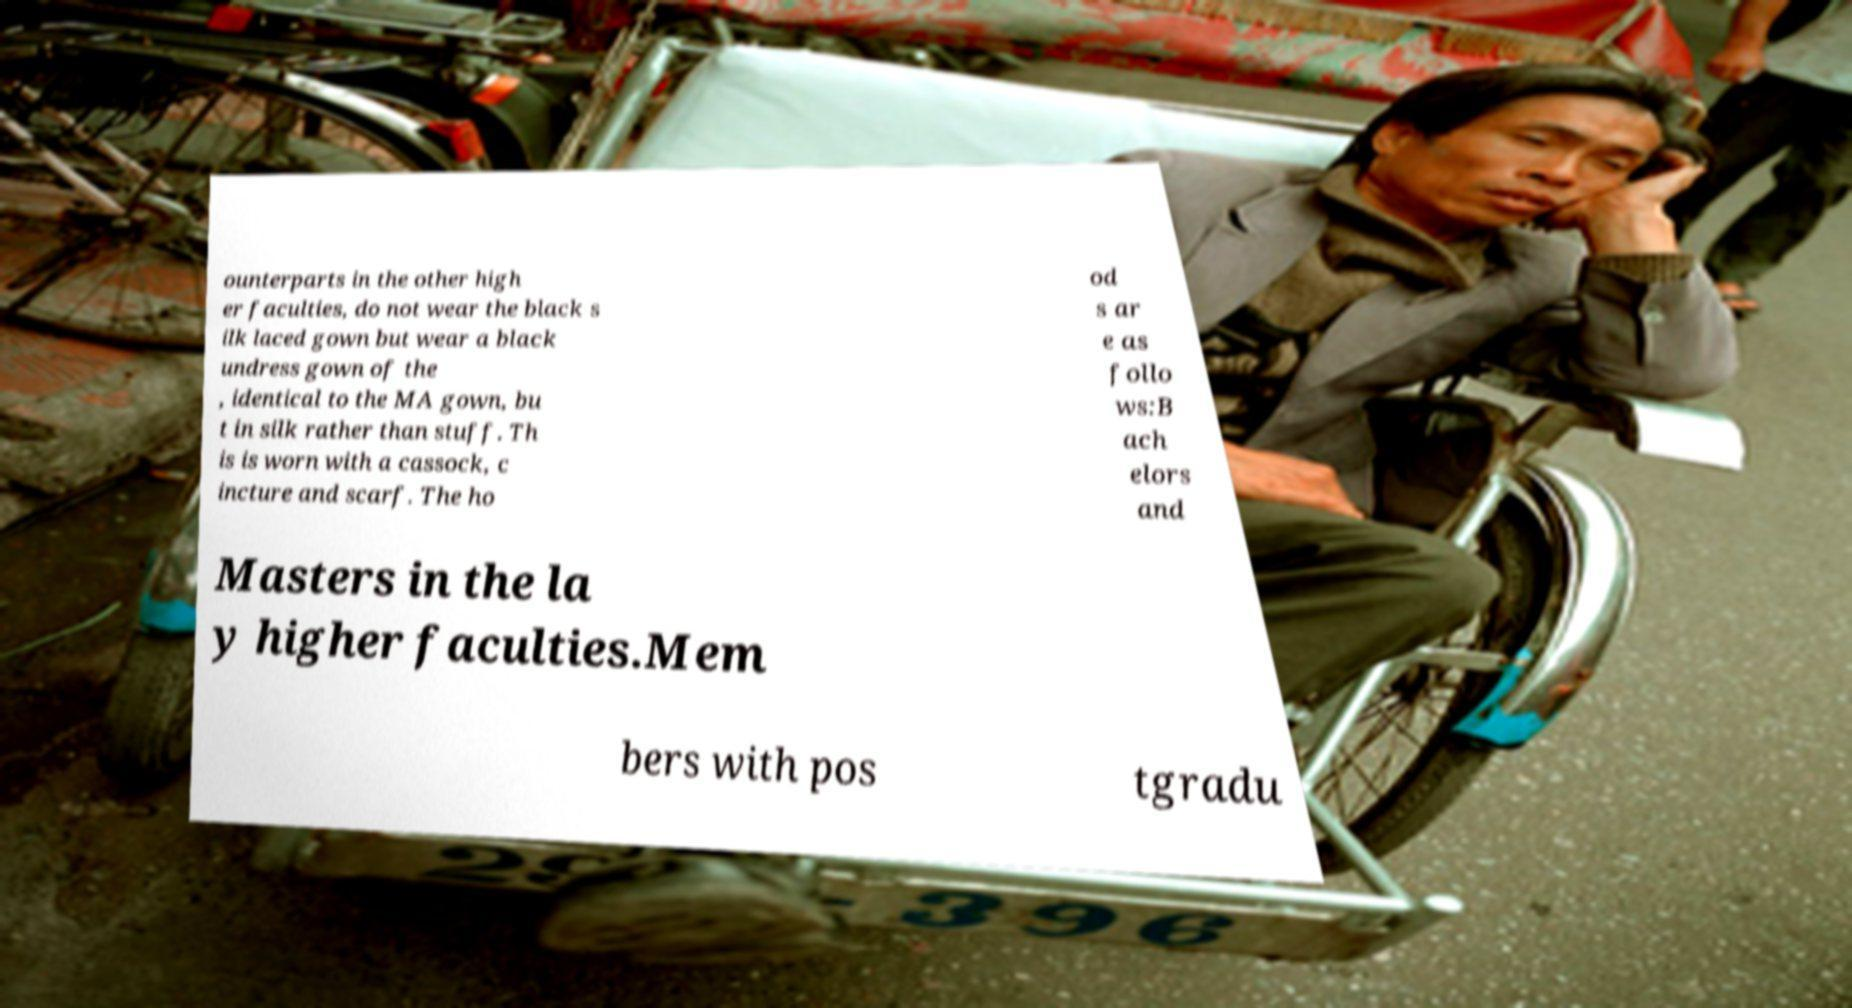Could you assist in decoding the text presented in this image and type it out clearly? ounterparts in the other high er faculties, do not wear the black s ilk laced gown but wear a black undress gown of the , identical to the MA gown, bu t in silk rather than stuff. Th is is worn with a cassock, c incture and scarf. The ho od s ar e as follo ws:B ach elors and Masters in the la y higher faculties.Mem bers with pos tgradu 